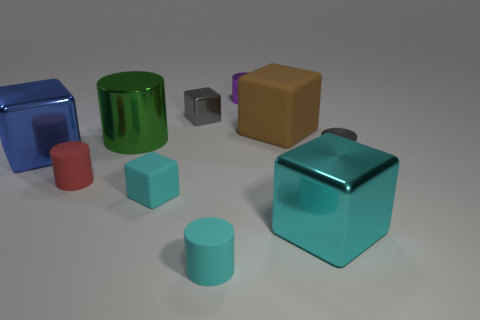How many cyan cubes must be subtracted to get 1 cyan cubes? 1 Subtract all purple shiny cylinders. How many cylinders are left? 4 Subtract all purple cylinders. How many cyan cubes are left? 2 Subtract all brown cubes. How many cubes are left? 4 Subtract all purple cylinders. Subtract all yellow balls. How many cylinders are left? 4 Add 5 purple objects. How many purple objects are left? 6 Add 5 large blue metallic things. How many large blue metallic things exist? 6 Subtract 0 yellow cylinders. How many objects are left? 10 Subtract all large objects. Subtract all tiny purple objects. How many objects are left? 5 